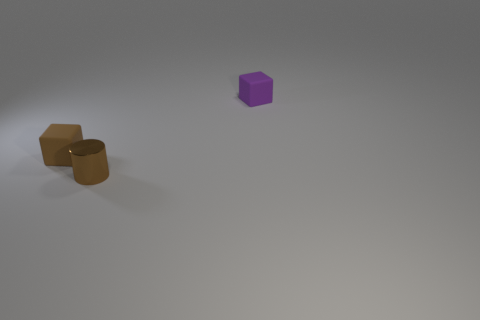There is a brown rubber thing; is its shape the same as the tiny matte thing to the right of the cylinder?
Give a very brief answer. Yes. How big is the brown block?
Your response must be concise. Small. Is the number of purple cubes that are to the left of the tiny metal thing less than the number of brown objects?
Give a very brief answer. Yes. How many other matte cubes have the same size as the brown cube?
Make the answer very short. 1. What is the shape of the tiny thing that is the same color as the small shiny cylinder?
Offer a terse response. Cube. There is a object that is left of the tiny shiny cylinder; does it have the same color as the tiny rubber cube that is on the right side of the metallic cylinder?
Ensure brevity in your answer.  No. There is a shiny object; how many small rubber blocks are to the left of it?
Your response must be concise. 1. What size is the rubber cube that is the same color as the small shiny thing?
Offer a terse response. Small. Are there any other shiny things that have the same shape as the metal object?
Offer a very short reply. No. There is a cylinder that is the same size as the brown matte object; what is its color?
Give a very brief answer. Brown. 